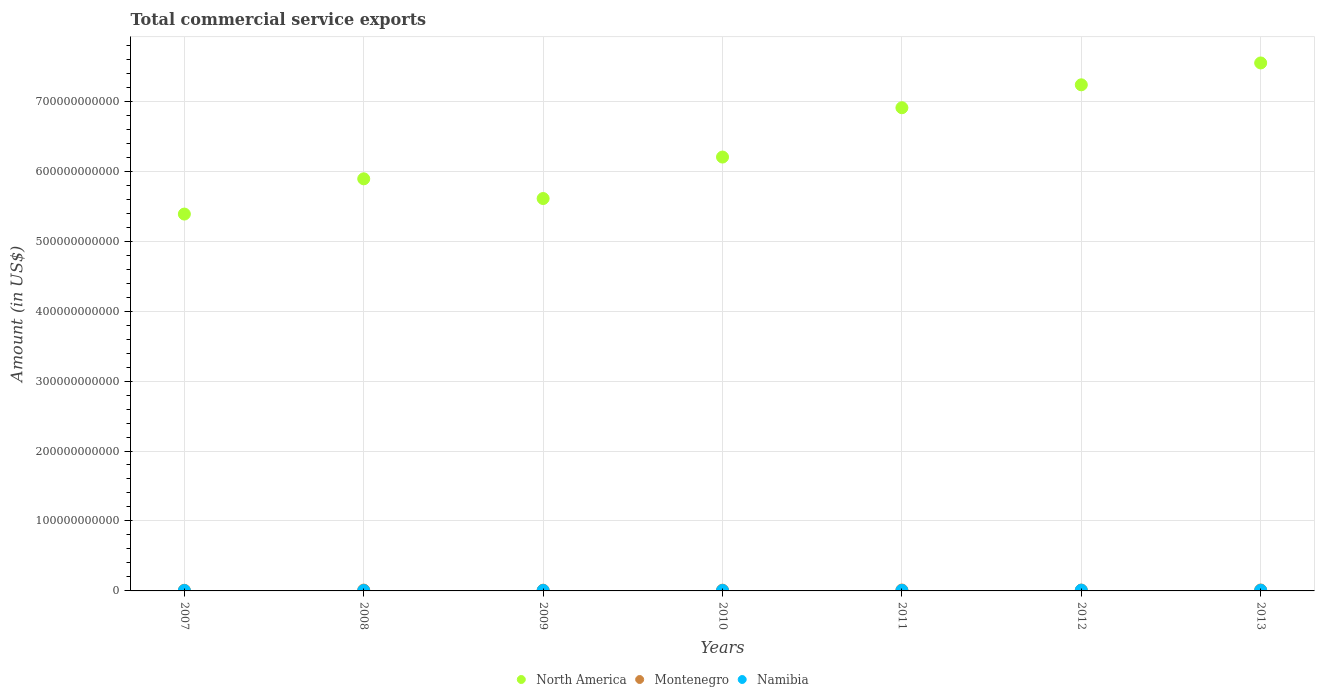Is the number of dotlines equal to the number of legend labels?
Provide a succinct answer. Yes. What is the total commercial service exports in North America in 2012?
Ensure brevity in your answer.  7.23e+11. Across all years, what is the maximum total commercial service exports in Montenegro?
Your answer should be compact. 1.32e+09. Across all years, what is the minimum total commercial service exports in Namibia?
Give a very brief answer. 5.38e+08. What is the total total commercial service exports in Namibia in the graph?
Offer a terse response. 5.11e+09. What is the difference between the total commercial service exports in Montenegro in 2007 and that in 2008?
Give a very brief answer. -2.60e+08. What is the difference between the total commercial service exports in North America in 2011 and the total commercial service exports in Montenegro in 2010?
Give a very brief answer. 6.90e+11. What is the average total commercial service exports in Montenegro per year?
Your answer should be very brief. 1.15e+09. In the year 2013, what is the difference between the total commercial service exports in North America and total commercial service exports in Namibia?
Offer a very short reply. 7.54e+11. In how many years, is the total commercial service exports in North America greater than 700000000000 US$?
Provide a succinct answer. 2. What is the ratio of the total commercial service exports in Namibia in 2011 to that in 2013?
Offer a very short reply. 0.79. Is the total commercial service exports in Montenegro in 2008 less than that in 2010?
Provide a succinct answer. No. Is the difference between the total commercial service exports in North America in 2007 and 2010 greater than the difference between the total commercial service exports in Namibia in 2007 and 2010?
Give a very brief answer. No. What is the difference between the highest and the second highest total commercial service exports in Namibia?
Make the answer very short. 1.48e+08. What is the difference between the highest and the lowest total commercial service exports in Montenegro?
Ensure brevity in your answer.  3.84e+08. Is the sum of the total commercial service exports in North America in 2010 and 2011 greater than the maximum total commercial service exports in Namibia across all years?
Offer a terse response. Yes. Is it the case that in every year, the sum of the total commercial service exports in Namibia and total commercial service exports in Montenegro  is greater than the total commercial service exports in North America?
Your answer should be compact. No. Does the total commercial service exports in Montenegro monotonically increase over the years?
Provide a short and direct response. No. Is the total commercial service exports in Montenegro strictly greater than the total commercial service exports in North America over the years?
Give a very brief answer. No. What is the difference between two consecutive major ticks on the Y-axis?
Your answer should be compact. 1.00e+11. Are the values on the major ticks of Y-axis written in scientific E-notation?
Offer a terse response. No. How many legend labels are there?
Your response must be concise. 3. How are the legend labels stacked?
Your answer should be compact. Horizontal. What is the title of the graph?
Your response must be concise. Total commercial service exports. Does "Libya" appear as one of the legend labels in the graph?
Your response must be concise. No. What is the label or title of the X-axis?
Your response must be concise. Years. What is the Amount (in US$) of North America in 2007?
Your response must be concise. 5.39e+11. What is the Amount (in US$) in Montenegro in 2007?
Make the answer very short. 9.33e+08. What is the Amount (in US$) in Namibia in 2007?
Keep it short and to the point. 5.79e+08. What is the Amount (in US$) in North America in 2008?
Provide a succinct answer. 5.89e+11. What is the Amount (in US$) in Montenegro in 2008?
Give a very brief answer. 1.19e+09. What is the Amount (in US$) of Namibia in 2008?
Your response must be concise. 5.38e+08. What is the Amount (in US$) in North America in 2009?
Make the answer very short. 5.61e+11. What is the Amount (in US$) of Montenegro in 2009?
Make the answer very short. 1.05e+09. What is the Amount (in US$) of Namibia in 2009?
Provide a short and direct response. 6.38e+08. What is the Amount (in US$) of North America in 2010?
Your answer should be compact. 6.20e+11. What is the Amount (in US$) in Montenegro in 2010?
Your answer should be compact. 1.05e+09. What is the Amount (in US$) of Namibia in 2010?
Offer a terse response. 6.64e+08. What is the Amount (in US$) of North America in 2011?
Give a very brief answer. 6.91e+11. What is the Amount (in US$) in Montenegro in 2011?
Provide a succinct answer. 1.28e+09. What is the Amount (in US$) in Namibia in 2011?
Provide a short and direct response. 7.23e+08. What is the Amount (in US$) in North America in 2012?
Make the answer very short. 7.23e+11. What is the Amount (in US$) of Montenegro in 2012?
Offer a very short reply. 1.21e+09. What is the Amount (in US$) in Namibia in 2012?
Provide a succinct answer. 1.06e+09. What is the Amount (in US$) of North America in 2013?
Keep it short and to the point. 7.55e+11. What is the Amount (in US$) in Montenegro in 2013?
Make the answer very short. 1.32e+09. What is the Amount (in US$) in Namibia in 2013?
Provide a short and direct response. 9.12e+08. Across all years, what is the maximum Amount (in US$) of North America?
Give a very brief answer. 7.55e+11. Across all years, what is the maximum Amount (in US$) of Montenegro?
Provide a short and direct response. 1.32e+09. Across all years, what is the maximum Amount (in US$) in Namibia?
Provide a succinct answer. 1.06e+09. Across all years, what is the minimum Amount (in US$) in North America?
Your response must be concise. 5.39e+11. Across all years, what is the minimum Amount (in US$) of Montenegro?
Your answer should be very brief. 9.33e+08. Across all years, what is the minimum Amount (in US$) in Namibia?
Keep it short and to the point. 5.38e+08. What is the total Amount (in US$) of North America in the graph?
Offer a very short reply. 4.48e+12. What is the total Amount (in US$) of Montenegro in the graph?
Provide a short and direct response. 8.04e+09. What is the total Amount (in US$) of Namibia in the graph?
Offer a very short reply. 5.11e+09. What is the difference between the Amount (in US$) in North America in 2007 and that in 2008?
Give a very brief answer. -5.04e+1. What is the difference between the Amount (in US$) of Montenegro in 2007 and that in 2008?
Keep it short and to the point. -2.60e+08. What is the difference between the Amount (in US$) of Namibia in 2007 and that in 2008?
Your answer should be compact. 4.13e+07. What is the difference between the Amount (in US$) of North America in 2007 and that in 2009?
Provide a succinct answer. -2.22e+1. What is the difference between the Amount (in US$) in Montenegro in 2007 and that in 2009?
Provide a succinct answer. -1.20e+08. What is the difference between the Amount (in US$) in Namibia in 2007 and that in 2009?
Your answer should be compact. -5.82e+07. What is the difference between the Amount (in US$) of North America in 2007 and that in 2010?
Make the answer very short. -8.15e+1. What is the difference between the Amount (in US$) in Montenegro in 2007 and that in 2010?
Offer a terse response. -1.20e+08. What is the difference between the Amount (in US$) of Namibia in 2007 and that in 2010?
Your answer should be compact. -8.48e+07. What is the difference between the Amount (in US$) of North America in 2007 and that in 2011?
Your response must be concise. -1.52e+11. What is the difference between the Amount (in US$) of Montenegro in 2007 and that in 2011?
Ensure brevity in your answer.  -3.43e+08. What is the difference between the Amount (in US$) of Namibia in 2007 and that in 2011?
Make the answer very short. -1.44e+08. What is the difference between the Amount (in US$) of North America in 2007 and that in 2012?
Keep it short and to the point. -1.85e+11. What is the difference between the Amount (in US$) in Montenegro in 2007 and that in 2012?
Your answer should be compact. -2.78e+08. What is the difference between the Amount (in US$) in Namibia in 2007 and that in 2012?
Ensure brevity in your answer.  -4.80e+08. What is the difference between the Amount (in US$) of North America in 2007 and that in 2013?
Your answer should be very brief. -2.16e+11. What is the difference between the Amount (in US$) of Montenegro in 2007 and that in 2013?
Offer a very short reply. -3.84e+08. What is the difference between the Amount (in US$) in Namibia in 2007 and that in 2013?
Make the answer very short. -3.32e+08. What is the difference between the Amount (in US$) in North America in 2008 and that in 2009?
Your answer should be very brief. 2.82e+1. What is the difference between the Amount (in US$) of Montenegro in 2008 and that in 2009?
Make the answer very short. 1.40e+08. What is the difference between the Amount (in US$) of Namibia in 2008 and that in 2009?
Your response must be concise. -9.95e+07. What is the difference between the Amount (in US$) in North America in 2008 and that in 2010?
Your response must be concise. -3.11e+1. What is the difference between the Amount (in US$) in Montenegro in 2008 and that in 2010?
Make the answer very short. 1.39e+08. What is the difference between the Amount (in US$) in Namibia in 2008 and that in 2010?
Provide a succinct answer. -1.26e+08. What is the difference between the Amount (in US$) in North America in 2008 and that in 2011?
Make the answer very short. -1.02e+11. What is the difference between the Amount (in US$) of Montenegro in 2008 and that in 2011?
Provide a short and direct response. -8.31e+07. What is the difference between the Amount (in US$) of Namibia in 2008 and that in 2011?
Provide a succinct answer. -1.85e+08. What is the difference between the Amount (in US$) of North America in 2008 and that in 2012?
Your answer should be compact. -1.34e+11. What is the difference between the Amount (in US$) of Montenegro in 2008 and that in 2012?
Provide a short and direct response. -1.82e+07. What is the difference between the Amount (in US$) of Namibia in 2008 and that in 2012?
Provide a succinct answer. -5.21e+08. What is the difference between the Amount (in US$) in North America in 2008 and that in 2013?
Offer a terse response. -1.66e+11. What is the difference between the Amount (in US$) of Montenegro in 2008 and that in 2013?
Provide a short and direct response. -1.24e+08. What is the difference between the Amount (in US$) of Namibia in 2008 and that in 2013?
Give a very brief answer. -3.74e+08. What is the difference between the Amount (in US$) in North America in 2009 and that in 2010?
Provide a succinct answer. -5.93e+1. What is the difference between the Amount (in US$) of Montenegro in 2009 and that in 2010?
Ensure brevity in your answer.  -4.38e+05. What is the difference between the Amount (in US$) in Namibia in 2009 and that in 2010?
Your answer should be very brief. -2.66e+07. What is the difference between the Amount (in US$) of North America in 2009 and that in 2011?
Provide a short and direct response. -1.30e+11. What is the difference between the Amount (in US$) of Montenegro in 2009 and that in 2011?
Provide a succinct answer. -2.23e+08. What is the difference between the Amount (in US$) in Namibia in 2009 and that in 2011?
Keep it short and to the point. -8.56e+07. What is the difference between the Amount (in US$) in North America in 2009 and that in 2012?
Ensure brevity in your answer.  -1.63e+11. What is the difference between the Amount (in US$) in Montenegro in 2009 and that in 2012?
Your answer should be very brief. -1.58e+08. What is the difference between the Amount (in US$) of Namibia in 2009 and that in 2012?
Offer a terse response. -4.22e+08. What is the difference between the Amount (in US$) in North America in 2009 and that in 2013?
Give a very brief answer. -1.94e+11. What is the difference between the Amount (in US$) in Montenegro in 2009 and that in 2013?
Give a very brief answer. -2.64e+08. What is the difference between the Amount (in US$) in Namibia in 2009 and that in 2013?
Your answer should be compact. -2.74e+08. What is the difference between the Amount (in US$) in North America in 2010 and that in 2011?
Your response must be concise. -7.05e+1. What is the difference between the Amount (in US$) in Montenegro in 2010 and that in 2011?
Your response must be concise. -2.23e+08. What is the difference between the Amount (in US$) in Namibia in 2010 and that in 2011?
Offer a terse response. -5.90e+07. What is the difference between the Amount (in US$) in North America in 2010 and that in 2012?
Provide a short and direct response. -1.03e+11. What is the difference between the Amount (in US$) of Montenegro in 2010 and that in 2012?
Offer a very short reply. -1.58e+08. What is the difference between the Amount (in US$) in Namibia in 2010 and that in 2012?
Offer a very short reply. -3.95e+08. What is the difference between the Amount (in US$) in North America in 2010 and that in 2013?
Your response must be concise. -1.35e+11. What is the difference between the Amount (in US$) in Montenegro in 2010 and that in 2013?
Give a very brief answer. -2.64e+08. What is the difference between the Amount (in US$) in Namibia in 2010 and that in 2013?
Give a very brief answer. -2.48e+08. What is the difference between the Amount (in US$) of North America in 2011 and that in 2012?
Make the answer very short. -3.27e+1. What is the difference between the Amount (in US$) in Montenegro in 2011 and that in 2012?
Offer a very short reply. 6.48e+07. What is the difference between the Amount (in US$) of Namibia in 2011 and that in 2012?
Your response must be concise. -3.36e+08. What is the difference between the Amount (in US$) in North America in 2011 and that in 2013?
Ensure brevity in your answer.  -6.40e+1. What is the difference between the Amount (in US$) in Montenegro in 2011 and that in 2013?
Keep it short and to the point. -4.14e+07. What is the difference between the Amount (in US$) of Namibia in 2011 and that in 2013?
Your answer should be very brief. -1.89e+08. What is the difference between the Amount (in US$) in North America in 2012 and that in 2013?
Your answer should be very brief. -3.12e+1. What is the difference between the Amount (in US$) in Montenegro in 2012 and that in 2013?
Provide a succinct answer. -1.06e+08. What is the difference between the Amount (in US$) in Namibia in 2012 and that in 2013?
Your response must be concise. 1.48e+08. What is the difference between the Amount (in US$) in North America in 2007 and the Amount (in US$) in Montenegro in 2008?
Ensure brevity in your answer.  5.38e+11. What is the difference between the Amount (in US$) in North America in 2007 and the Amount (in US$) in Namibia in 2008?
Provide a short and direct response. 5.38e+11. What is the difference between the Amount (in US$) of Montenegro in 2007 and the Amount (in US$) of Namibia in 2008?
Offer a very short reply. 3.95e+08. What is the difference between the Amount (in US$) of North America in 2007 and the Amount (in US$) of Montenegro in 2009?
Provide a succinct answer. 5.38e+11. What is the difference between the Amount (in US$) in North America in 2007 and the Amount (in US$) in Namibia in 2009?
Provide a short and direct response. 5.38e+11. What is the difference between the Amount (in US$) of Montenegro in 2007 and the Amount (in US$) of Namibia in 2009?
Provide a succinct answer. 2.96e+08. What is the difference between the Amount (in US$) in North America in 2007 and the Amount (in US$) in Montenegro in 2010?
Make the answer very short. 5.38e+11. What is the difference between the Amount (in US$) of North America in 2007 and the Amount (in US$) of Namibia in 2010?
Offer a very short reply. 5.38e+11. What is the difference between the Amount (in US$) of Montenegro in 2007 and the Amount (in US$) of Namibia in 2010?
Offer a terse response. 2.69e+08. What is the difference between the Amount (in US$) of North America in 2007 and the Amount (in US$) of Montenegro in 2011?
Your response must be concise. 5.37e+11. What is the difference between the Amount (in US$) in North America in 2007 and the Amount (in US$) in Namibia in 2011?
Provide a short and direct response. 5.38e+11. What is the difference between the Amount (in US$) in Montenegro in 2007 and the Amount (in US$) in Namibia in 2011?
Offer a very short reply. 2.10e+08. What is the difference between the Amount (in US$) in North America in 2007 and the Amount (in US$) in Montenegro in 2012?
Keep it short and to the point. 5.37e+11. What is the difference between the Amount (in US$) in North America in 2007 and the Amount (in US$) in Namibia in 2012?
Your answer should be very brief. 5.38e+11. What is the difference between the Amount (in US$) in Montenegro in 2007 and the Amount (in US$) in Namibia in 2012?
Offer a very short reply. -1.26e+08. What is the difference between the Amount (in US$) of North America in 2007 and the Amount (in US$) of Montenegro in 2013?
Ensure brevity in your answer.  5.37e+11. What is the difference between the Amount (in US$) in North America in 2007 and the Amount (in US$) in Namibia in 2013?
Offer a very short reply. 5.38e+11. What is the difference between the Amount (in US$) of Montenegro in 2007 and the Amount (in US$) of Namibia in 2013?
Provide a succinct answer. 2.16e+07. What is the difference between the Amount (in US$) in North America in 2008 and the Amount (in US$) in Montenegro in 2009?
Your answer should be very brief. 5.88e+11. What is the difference between the Amount (in US$) in North America in 2008 and the Amount (in US$) in Namibia in 2009?
Provide a succinct answer. 5.88e+11. What is the difference between the Amount (in US$) in Montenegro in 2008 and the Amount (in US$) in Namibia in 2009?
Make the answer very short. 5.55e+08. What is the difference between the Amount (in US$) of North America in 2008 and the Amount (in US$) of Montenegro in 2010?
Provide a short and direct response. 5.88e+11. What is the difference between the Amount (in US$) in North America in 2008 and the Amount (in US$) in Namibia in 2010?
Keep it short and to the point. 5.88e+11. What is the difference between the Amount (in US$) of Montenegro in 2008 and the Amount (in US$) of Namibia in 2010?
Make the answer very short. 5.29e+08. What is the difference between the Amount (in US$) in North America in 2008 and the Amount (in US$) in Montenegro in 2011?
Your answer should be very brief. 5.88e+11. What is the difference between the Amount (in US$) of North America in 2008 and the Amount (in US$) of Namibia in 2011?
Your response must be concise. 5.88e+11. What is the difference between the Amount (in US$) of Montenegro in 2008 and the Amount (in US$) of Namibia in 2011?
Your answer should be very brief. 4.70e+08. What is the difference between the Amount (in US$) of North America in 2008 and the Amount (in US$) of Montenegro in 2012?
Your answer should be very brief. 5.88e+11. What is the difference between the Amount (in US$) of North America in 2008 and the Amount (in US$) of Namibia in 2012?
Your answer should be compact. 5.88e+11. What is the difference between the Amount (in US$) in Montenegro in 2008 and the Amount (in US$) in Namibia in 2012?
Offer a very short reply. 1.34e+08. What is the difference between the Amount (in US$) in North America in 2008 and the Amount (in US$) in Montenegro in 2013?
Offer a terse response. 5.88e+11. What is the difference between the Amount (in US$) of North America in 2008 and the Amount (in US$) of Namibia in 2013?
Give a very brief answer. 5.88e+11. What is the difference between the Amount (in US$) in Montenegro in 2008 and the Amount (in US$) in Namibia in 2013?
Provide a succinct answer. 2.81e+08. What is the difference between the Amount (in US$) in North America in 2009 and the Amount (in US$) in Montenegro in 2010?
Your answer should be compact. 5.60e+11. What is the difference between the Amount (in US$) of North America in 2009 and the Amount (in US$) of Namibia in 2010?
Your answer should be compact. 5.60e+11. What is the difference between the Amount (in US$) of Montenegro in 2009 and the Amount (in US$) of Namibia in 2010?
Offer a terse response. 3.89e+08. What is the difference between the Amount (in US$) of North America in 2009 and the Amount (in US$) of Montenegro in 2011?
Give a very brief answer. 5.60e+11. What is the difference between the Amount (in US$) of North America in 2009 and the Amount (in US$) of Namibia in 2011?
Ensure brevity in your answer.  5.60e+11. What is the difference between the Amount (in US$) of Montenegro in 2009 and the Amount (in US$) of Namibia in 2011?
Give a very brief answer. 3.30e+08. What is the difference between the Amount (in US$) in North America in 2009 and the Amount (in US$) in Montenegro in 2012?
Provide a short and direct response. 5.60e+11. What is the difference between the Amount (in US$) in North America in 2009 and the Amount (in US$) in Namibia in 2012?
Your answer should be very brief. 5.60e+11. What is the difference between the Amount (in US$) in Montenegro in 2009 and the Amount (in US$) in Namibia in 2012?
Your answer should be compact. -6.33e+06. What is the difference between the Amount (in US$) of North America in 2009 and the Amount (in US$) of Montenegro in 2013?
Provide a succinct answer. 5.60e+11. What is the difference between the Amount (in US$) of North America in 2009 and the Amount (in US$) of Namibia in 2013?
Give a very brief answer. 5.60e+11. What is the difference between the Amount (in US$) in Montenegro in 2009 and the Amount (in US$) in Namibia in 2013?
Your response must be concise. 1.41e+08. What is the difference between the Amount (in US$) in North America in 2010 and the Amount (in US$) in Montenegro in 2011?
Provide a succinct answer. 6.19e+11. What is the difference between the Amount (in US$) of North America in 2010 and the Amount (in US$) of Namibia in 2011?
Your answer should be compact. 6.19e+11. What is the difference between the Amount (in US$) in Montenegro in 2010 and the Amount (in US$) in Namibia in 2011?
Offer a very short reply. 3.30e+08. What is the difference between the Amount (in US$) in North America in 2010 and the Amount (in US$) in Montenegro in 2012?
Make the answer very short. 6.19e+11. What is the difference between the Amount (in US$) in North America in 2010 and the Amount (in US$) in Namibia in 2012?
Ensure brevity in your answer.  6.19e+11. What is the difference between the Amount (in US$) in Montenegro in 2010 and the Amount (in US$) in Namibia in 2012?
Your answer should be compact. -5.89e+06. What is the difference between the Amount (in US$) in North America in 2010 and the Amount (in US$) in Montenegro in 2013?
Make the answer very short. 6.19e+11. What is the difference between the Amount (in US$) of North America in 2010 and the Amount (in US$) of Namibia in 2013?
Give a very brief answer. 6.19e+11. What is the difference between the Amount (in US$) in Montenegro in 2010 and the Amount (in US$) in Namibia in 2013?
Keep it short and to the point. 1.42e+08. What is the difference between the Amount (in US$) in North America in 2011 and the Amount (in US$) in Montenegro in 2012?
Offer a very short reply. 6.89e+11. What is the difference between the Amount (in US$) in North America in 2011 and the Amount (in US$) in Namibia in 2012?
Give a very brief answer. 6.90e+11. What is the difference between the Amount (in US$) in Montenegro in 2011 and the Amount (in US$) in Namibia in 2012?
Make the answer very short. 2.17e+08. What is the difference between the Amount (in US$) of North America in 2011 and the Amount (in US$) of Montenegro in 2013?
Offer a very short reply. 6.89e+11. What is the difference between the Amount (in US$) of North America in 2011 and the Amount (in US$) of Namibia in 2013?
Your answer should be compact. 6.90e+11. What is the difference between the Amount (in US$) of Montenegro in 2011 and the Amount (in US$) of Namibia in 2013?
Keep it short and to the point. 3.64e+08. What is the difference between the Amount (in US$) of North America in 2012 and the Amount (in US$) of Montenegro in 2013?
Offer a terse response. 7.22e+11. What is the difference between the Amount (in US$) of North America in 2012 and the Amount (in US$) of Namibia in 2013?
Your answer should be compact. 7.23e+11. What is the difference between the Amount (in US$) in Montenegro in 2012 and the Amount (in US$) in Namibia in 2013?
Your answer should be compact. 2.99e+08. What is the average Amount (in US$) in North America per year?
Offer a very short reply. 6.40e+11. What is the average Amount (in US$) in Montenegro per year?
Keep it short and to the point. 1.15e+09. What is the average Amount (in US$) of Namibia per year?
Your answer should be very brief. 7.30e+08. In the year 2007, what is the difference between the Amount (in US$) of North America and Amount (in US$) of Montenegro?
Give a very brief answer. 5.38e+11. In the year 2007, what is the difference between the Amount (in US$) in North America and Amount (in US$) in Namibia?
Provide a succinct answer. 5.38e+11. In the year 2007, what is the difference between the Amount (in US$) in Montenegro and Amount (in US$) in Namibia?
Your answer should be compact. 3.54e+08. In the year 2008, what is the difference between the Amount (in US$) of North America and Amount (in US$) of Montenegro?
Offer a very short reply. 5.88e+11. In the year 2008, what is the difference between the Amount (in US$) in North America and Amount (in US$) in Namibia?
Keep it short and to the point. 5.89e+11. In the year 2008, what is the difference between the Amount (in US$) of Montenegro and Amount (in US$) of Namibia?
Offer a very short reply. 6.55e+08. In the year 2009, what is the difference between the Amount (in US$) in North America and Amount (in US$) in Montenegro?
Keep it short and to the point. 5.60e+11. In the year 2009, what is the difference between the Amount (in US$) of North America and Amount (in US$) of Namibia?
Your answer should be very brief. 5.60e+11. In the year 2009, what is the difference between the Amount (in US$) in Montenegro and Amount (in US$) in Namibia?
Your response must be concise. 4.15e+08. In the year 2010, what is the difference between the Amount (in US$) in North America and Amount (in US$) in Montenegro?
Your answer should be very brief. 6.19e+11. In the year 2010, what is the difference between the Amount (in US$) of North America and Amount (in US$) of Namibia?
Provide a succinct answer. 6.20e+11. In the year 2010, what is the difference between the Amount (in US$) in Montenegro and Amount (in US$) in Namibia?
Offer a very short reply. 3.89e+08. In the year 2011, what is the difference between the Amount (in US$) in North America and Amount (in US$) in Montenegro?
Give a very brief answer. 6.89e+11. In the year 2011, what is the difference between the Amount (in US$) of North America and Amount (in US$) of Namibia?
Give a very brief answer. 6.90e+11. In the year 2011, what is the difference between the Amount (in US$) of Montenegro and Amount (in US$) of Namibia?
Offer a very short reply. 5.53e+08. In the year 2012, what is the difference between the Amount (in US$) of North America and Amount (in US$) of Montenegro?
Provide a succinct answer. 7.22e+11. In the year 2012, what is the difference between the Amount (in US$) in North America and Amount (in US$) in Namibia?
Give a very brief answer. 7.22e+11. In the year 2012, what is the difference between the Amount (in US$) of Montenegro and Amount (in US$) of Namibia?
Give a very brief answer. 1.52e+08. In the year 2013, what is the difference between the Amount (in US$) of North America and Amount (in US$) of Montenegro?
Your answer should be very brief. 7.53e+11. In the year 2013, what is the difference between the Amount (in US$) of North America and Amount (in US$) of Namibia?
Keep it short and to the point. 7.54e+11. In the year 2013, what is the difference between the Amount (in US$) of Montenegro and Amount (in US$) of Namibia?
Your answer should be very brief. 4.06e+08. What is the ratio of the Amount (in US$) of North America in 2007 to that in 2008?
Provide a short and direct response. 0.91. What is the ratio of the Amount (in US$) in Montenegro in 2007 to that in 2008?
Give a very brief answer. 0.78. What is the ratio of the Amount (in US$) of Namibia in 2007 to that in 2008?
Ensure brevity in your answer.  1.08. What is the ratio of the Amount (in US$) of North America in 2007 to that in 2009?
Your response must be concise. 0.96. What is the ratio of the Amount (in US$) of Montenegro in 2007 to that in 2009?
Your response must be concise. 0.89. What is the ratio of the Amount (in US$) in Namibia in 2007 to that in 2009?
Offer a terse response. 0.91. What is the ratio of the Amount (in US$) of North America in 2007 to that in 2010?
Offer a very short reply. 0.87. What is the ratio of the Amount (in US$) of Montenegro in 2007 to that in 2010?
Ensure brevity in your answer.  0.89. What is the ratio of the Amount (in US$) in Namibia in 2007 to that in 2010?
Ensure brevity in your answer.  0.87. What is the ratio of the Amount (in US$) in North America in 2007 to that in 2011?
Offer a very short reply. 0.78. What is the ratio of the Amount (in US$) of Montenegro in 2007 to that in 2011?
Keep it short and to the point. 0.73. What is the ratio of the Amount (in US$) of Namibia in 2007 to that in 2011?
Your response must be concise. 0.8. What is the ratio of the Amount (in US$) in North America in 2007 to that in 2012?
Offer a very short reply. 0.74. What is the ratio of the Amount (in US$) in Montenegro in 2007 to that in 2012?
Offer a terse response. 0.77. What is the ratio of the Amount (in US$) in Namibia in 2007 to that in 2012?
Provide a short and direct response. 0.55. What is the ratio of the Amount (in US$) of North America in 2007 to that in 2013?
Your response must be concise. 0.71. What is the ratio of the Amount (in US$) in Montenegro in 2007 to that in 2013?
Offer a terse response. 0.71. What is the ratio of the Amount (in US$) of Namibia in 2007 to that in 2013?
Offer a terse response. 0.64. What is the ratio of the Amount (in US$) of North America in 2008 to that in 2009?
Provide a succinct answer. 1.05. What is the ratio of the Amount (in US$) of Montenegro in 2008 to that in 2009?
Provide a succinct answer. 1.13. What is the ratio of the Amount (in US$) in Namibia in 2008 to that in 2009?
Keep it short and to the point. 0.84. What is the ratio of the Amount (in US$) of North America in 2008 to that in 2010?
Offer a terse response. 0.95. What is the ratio of the Amount (in US$) of Montenegro in 2008 to that in 2010?
Give a very brief answer. 1.13. What is the ratio of the Amount (in US$) in Namibia in 2008 to that in 2010?
Offer a terse response. 0.81. What is the ratio of the Amount (in US$) of North America in 2008 to that in 2011?
Your answer should be compact. 0.85. What is the ratio of the Amount (in US$) in Montenegro in 2008 to that in 2011?
Your response must be concise. 0.93. What is the ratio of the Amount (in US$) of Namibia in 2008 to that in 2011?
Give a very brief answer. 0.74. What is the ratio of the Amount (in US$) of North America in 2008 to that in 2012?
Give a very brief answer. 0.81. What is the ratio of the Amount (in US$) of Montenegro in 2008 to that in 2012?
Provide a short and direct response. 0.98. What is the ratio of the Amount (in US$) of Namibia in 2008 to that in 2012?
Ensure brevity in your answer.  0.51. What is the ratio of the Amount (in US$) of North America in 2008 to that in 2013?
Ensure brevity in your answer.  0.78. What is the ratio of the Amount (in US$) of Montenegro in 2008 to that in 2013?
Your response must be concise. 0.91. What is the ratio of the Amount (in US$) of Namibia in 2008 to that in 2013?
Give a very brief answer. 0.59. What is the ratio of the Amount (in US$) of North America in 2009 to that in 2010?
Your response must be concise. 0.9. What is the ratio of the Amount (in US$) in Namibia in 2009 to that in 2010?
Make the answer very short. 0.96. What is the ratio of the Amount (in US$) in North America in 2009 to that in 2011?
Make the answer very short. 0.81. What is the ratio of the Amount (in US$) in Montenegro in 2009 to that in 2011?
Offer a terse response. 0.83. What is the ratio of the Amount (in US$) in Namibia in 2009 to that in 2011?
Ensure brevity in your answer.  0.88. What is the ratio of the Amount (in US$) in North America in 2009 to that in 2012?
Your response must be concise. 0.78. What is the ratio of the Amount (in US$) of Montenegro in 2009 to that in 2012?
Your answer should be compact. 0.87. What is the ratio of the Amount (in US$) in Namibia in 2009 to that in 2012?
Your answer should be compact. 0.6. What is the ratio of the Amount (in US$) of North America in 2009 to that in 2013?
Offer a terse response. 0.74. What is the ratio of the Amount (in US$) in Montenegro in 2009 to that in 2013?
Provide a short and direct response. 0.8. What is the ratio of the Amount (in US$) in Namibia in 2009 to that in 2013?
Keep it short and to the point. 0.7. What is the ratio of the Amount (in US$) in North America in 2010 to that in 2011?
Your response must be concise. 0.9. What is the ratio of the Amount (in US$) of Montenegro in 2010 to that in 2011?
Keep it short and to the point. 0.83. What is the ratio of the Amount (in US$) in Namibia in 2010 to that in 2011?
Your response must be concise. 0.92. What is the ratio of the Amount (in US$) in North America in 2010 to that in 2012?
Your answer should be compact. 0.86. What is the ratio of the Amount (in US$) of Montenegro in 2010 to that in 2012?
Offer a terse response. 0.87. What is the ratio of the Amount (in US$) of Namibia in 2010 to that in 2012?
Make the answer very short. 0.63. What is the ratio of the Amount (in US$) of North America in 2010 to that in 2013?
Your answer should be very brief. 0.82. What is the ratio of the Amount (in US$) in Montenegro in 2010 to that in 2013?
Your answer should be compact. 0.8. What is the ratio of the Amount (in US$) in Namibia in 2010 to that in 2013?
Keep it short and to the point. 0.73. What is the ratio of the Amount (in US$) of North America in 2011 to that in 2012?
Your answer should be compact. 0.95. What is the ratio of the Amount (in US$) in Montenegro in 2011 to that in 2012?
Offer a very short reply. 1.05. What is the ratio of the Amount (in US$) in Namibia in 2011 to that in 2012?
Make the answer very short. 0.68. What is the ratio of the Amount (in US$) of North America in 2011 to that in 2013?
Keep it short and to the point. 0.92. What is the ratio of the Amount (in US$) in Montenegro in 2011 to that in 2013?
Your answer should be very brief. 0.97. What is the ratio of the Amount (in US$) of Namibia in 2011 to that in 2013?
Ensure brevity in your answer.  0.79. What is the ratio of the Amount (in US$) in North America in 2012 to that in 2013?
Offer a terse response. 0.96. What is the ratio of the Amount (in US$) in Montenegro in 2012 to that in 2013?
Give a very brief answer. 0.92. What is the ratio of the Amount (in US$) of Namibia in 2012 to that in 2013?
Offer a very short reply. 1.16. What is the difference between the highest and the second highest Amount (in US$) in North America?
Provide a short and direct response. 3.12e+1. What is the difference between the highest and the second highest Amount (in US$) of Montenegro?
Your answer should be very brief. 4.14e+07. What is the difference between the highest and the second highest Amount (in US$) of Namibia?
Keep it short and to the point. 1.48e+08. What is the difference between the highest and the lowest Amount (in US$) of North America?
Give a very brief answer. 2.16e+11. What is the difference between the highest and the lowest Amount (in US$) of Montenegro?
Offer a terse response. 3.84e+08. What is the difference between the highest and the lowest Amount (in US$) in Namibia?
Make the answer very short. 5.21e+08. 